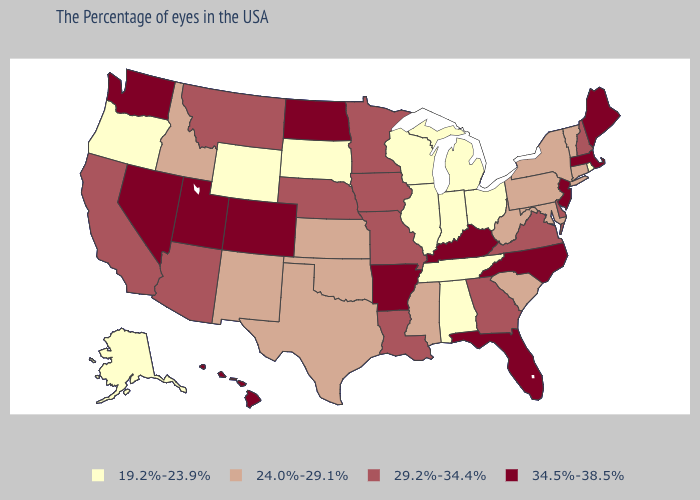Among the states that border Pennsylvania , does New York have the lowest value?
Keep it brief. No. Among the states that border Montana , does South Dakota have the lowest value?
Answer briefly. Yes. Name the states that have a value in the range 29.2%-34.4%?
Keep it brief. New Hampshire, Delaware, Virginia, Georgia, Louisiana, Missouri, Minnesota, Iowa, Nebraska, Montana, Arizona, California. Name the states that have a value in the range 34.5%-38.5%?
Give a very brief answer. Maine, Massachusetts, New Jersey, North Carolina, Florida, Kentucky, Arkansas, North Dakota, Colorado, Utah, Nevada, Washington, Hawaii. Does Hawaii have the highest value in the West?
Be succinct. Yes. Does Ohio have the same value as Washington?
Quick response, please. No. Does New Jersey have the lowest value in the USA?
Short answer required. No. Name the states that have a value in the range 29.2%-34.4%?
Keep it brief. New Hampshire, Delaware, Virginia, Georgia, Louisiana, Missouri, Minnesota, Iowa, Nebraska, Montana, Arizona, California. What is the lowest value in the USA?
Concise answer only. 19.2%-23.9%. Does Hawaii have the highest value in the USA?
Give a very brief answer. Yes. Does Maryland have the same value as Kansas?
Concise answer only. Yes. What is the lowest value in the South?
Write a very short answer. 19.2%-23.9%. Name the states that have a value in the range 29.2%-34.4%?
Quick response, please. New Hampshire, Delaware, Virginia, Georgia, Louisiana, Missouri, Minnesota, Iowa, Nebraska, Montana, Arizona, California. What is the highest value in the South ?
Short answer required. 34.5%-38.5%. Name the states that have a value in the range 19.2%-23.9%?
Write a very short answer. Rhode Island, Ohio, Michigan, Indiana, Alabama, Tennessee, Wisconsin, Illinois, South Dakota, Wyoming, Oregon, Alaska. 